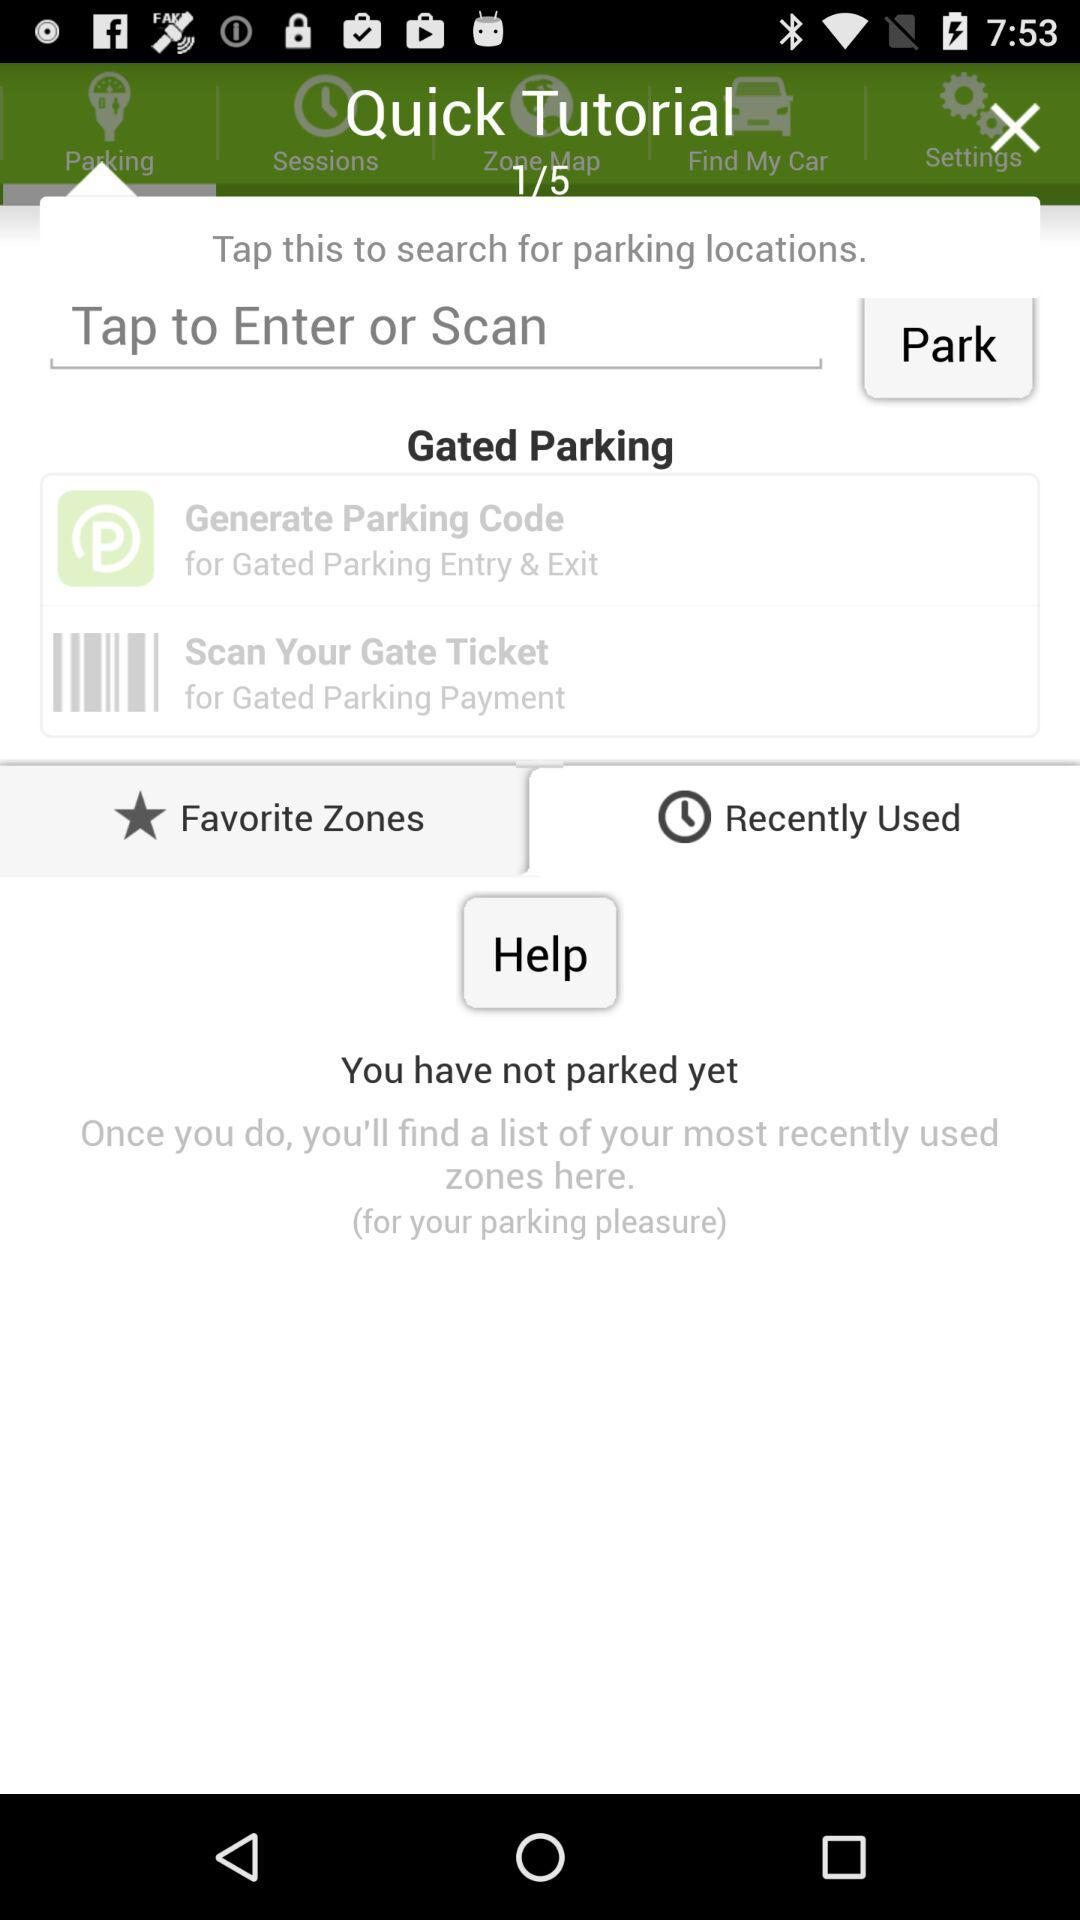What is the total number of "Quick Tutorial"? The total number of "Quick Tutorial" is 5. 